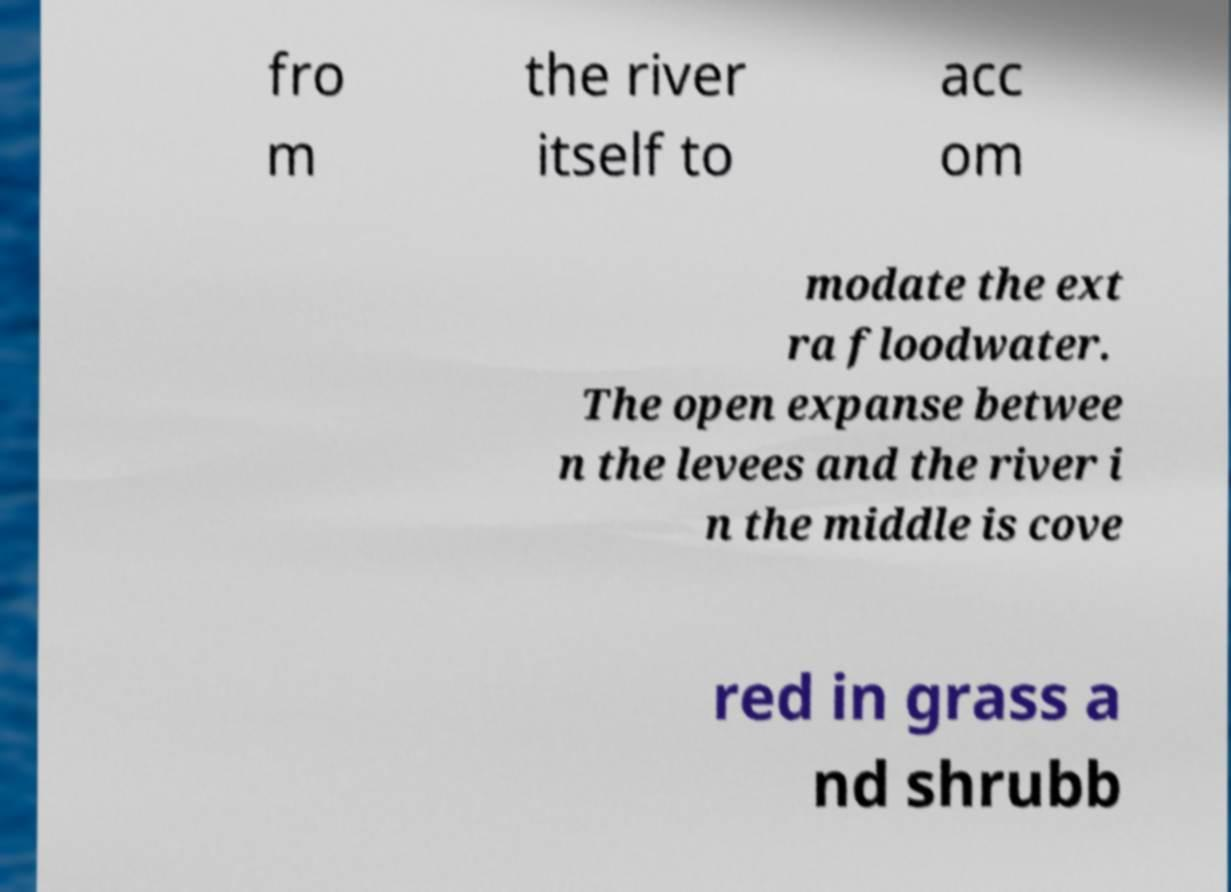Please identify and transcribe the text found in this image. fro m the river itself to acc om modate the ext ra floodwater. The open expanse betwee n the levees and the river i n the middle is cove red in grass a nd shrubb 